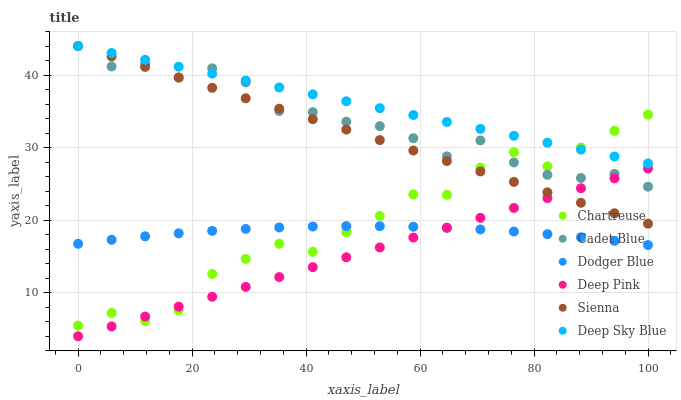Does Deep Pink have the minimum area under the curve?
Answer yes or no. Yes. Does Deep Sky Blue have the maximum area under the curve?
Answer yes or no. Yes. Does Sienna have the minimum area under the curve?
Answer yes or no. No. Does Sienna have the maximum area under the curve?
Answer yes or no. No. Is Deep Sky Blue the smoothest?
Answer yes or no. Yes. Is Chartreuse the roughest?
Answer yes or no. Yes. Is Sienna the smoothest?
Answer yes or no. No. Is Sienna the roughest?
Answer yes or no. No. Does Deep Pink have the lowest value?
Answer yes or no. Yes. Does Sienna have the lowest value?
Answer yes or no. No. Does Deep Sky Blue have the highest value?
Answer yes or no. Yes. Does Chartreuse have the highest value?
Answer yes or no. No. Is Dodger Blue less than Sienna?
Answer yes or no. Yes. Is Deep Sky Blue greater than Dodger Blue?
Answer yes or no. Yes. Does Sienna intersect Cadet Blue?
Answer yes or no. Yes. Is Sienna less than Cadet Blue?
Answer yes or no. No. Is Sienna greater than Cadet Blue?
Answer yes or no. No. Does Dodger Blue intersect Sienna?
Answer yes or no. No. 